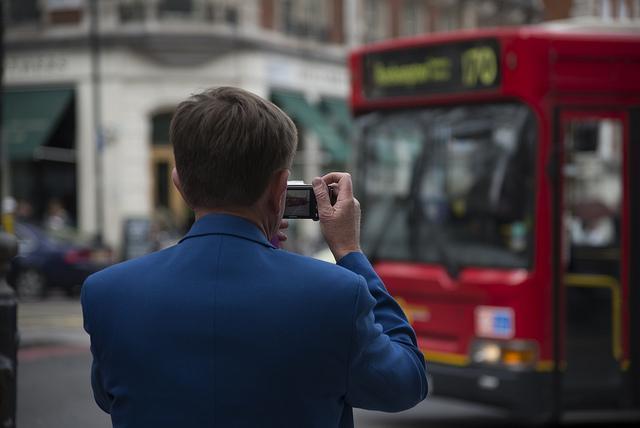What is the person in blue coat doing?
Pick the right solution, then justify: 'Answer: answer
Rationale: rationale.'
Options: Sending email, taking photo, watching video, online shopping. Answer: taking photo.
Rationale: The man in the blue coat is taking a picture. 